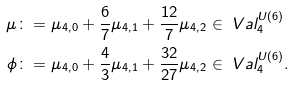Convert formula to latex. <formula><loc_0><loc_0><loc_500><loc_500>\mu & \colon = \mu _ { 4 , 0 } + \frac { 6 } { 7 } \mu _ { 4 , 1 } + \frac { 1 2 } { 7 } \mu _ { 4 , 2 } \in \ V a l _ { 4 } ^ { U ( 6 ) } \\ \phi & \colon = \mu _ { 4 , 0 } + \frac { 4 } { 3 } \mu _ { 4 , 1 } + \frac { 3 2 } { 2 7 } \mu _ { 4 , 2 } \in \ V a l _ { 4 } ^ { U ( 6 ) } .</formula> 